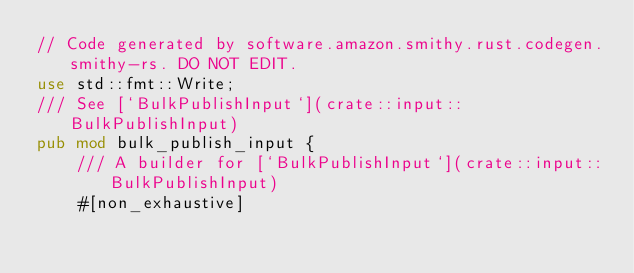<code> <loc_0><loc_0><loc_500><loc_500><_Rust_>// Code generated by software.amazon.smithy.rust.codegen.smithy-rs. DO NOT EDIT.
use std::fmt::Write;
/// See [`BulkPublishInput`](crate::input::BulkPublishInput)
pub mod bulk_publish_input {
    /// A builder for [`BulkPublishInput`](crate::input::BulkPublishInput)
    #[non_exhaustive]</code> 